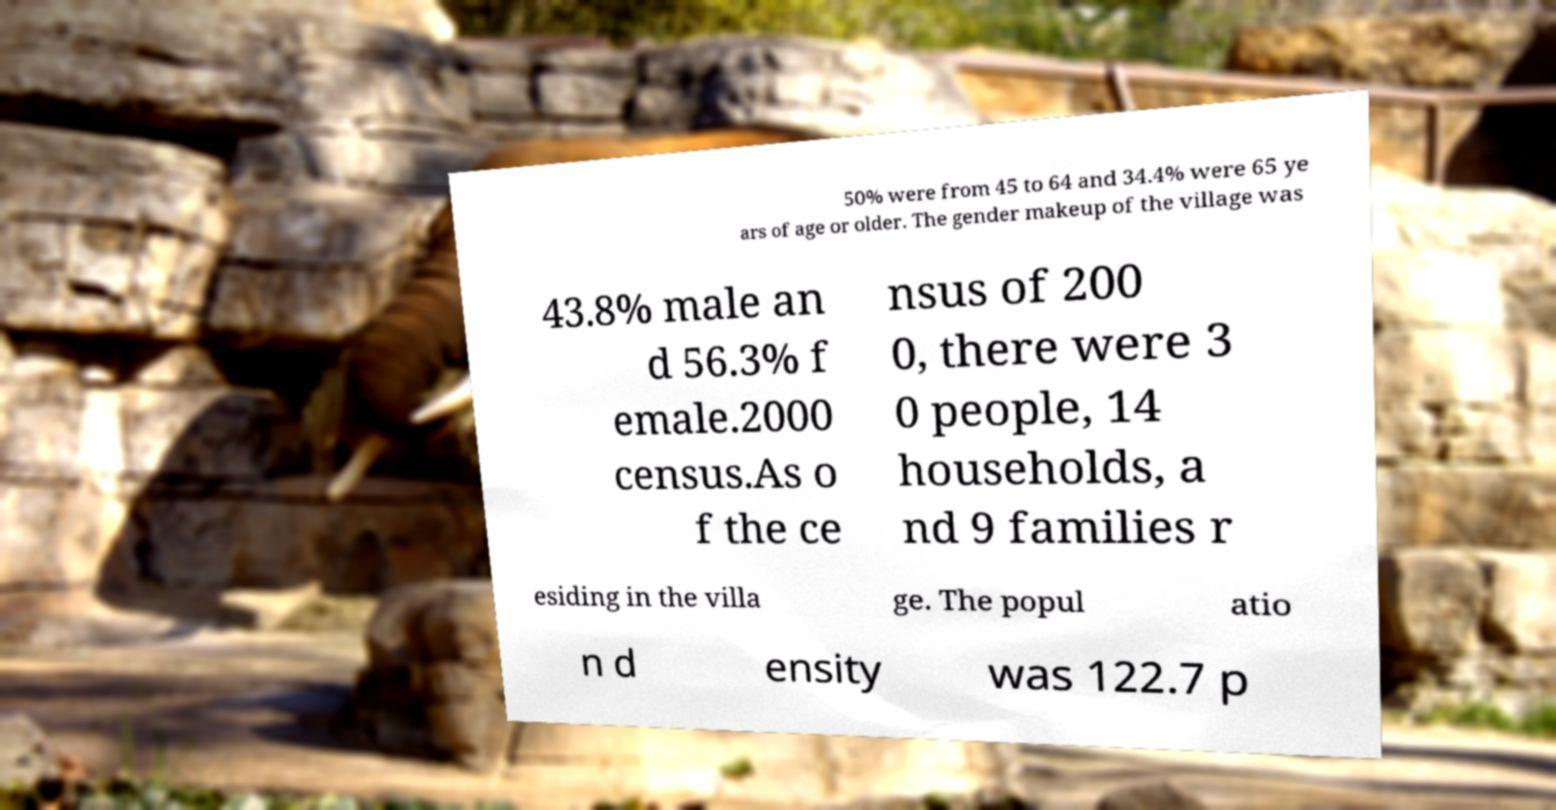What messages or text are displayed in this image? I need them in a readable, typed format. 50% were from 45 to 64 and 34.4% were 65 ye ars of age or older. The gender makeup of the village was 43.8% male an d 56.3% f emale.2000 census.As o f the ce nsus of 200 0, there were 3 0 people, 14 households, a nd 9 families r esiding in the villa ge. The popul atio n d ensity was 122.7 p 